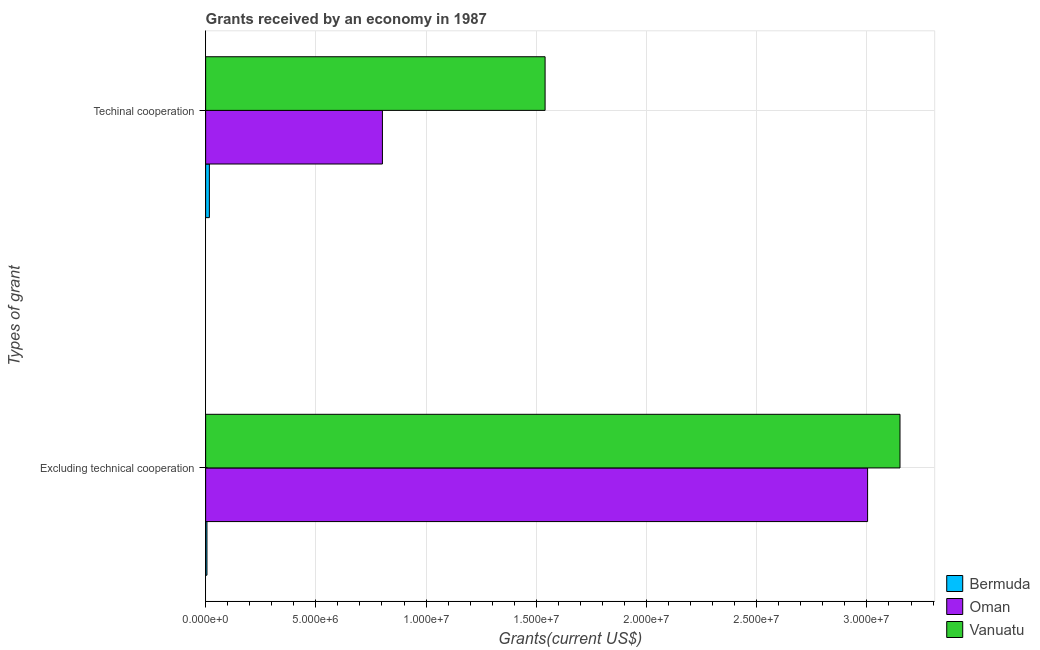How many groups of bars are there?
Provide a short and direct response. 2. Are the number of bars per tick equal to the number of legend labels?
Provide a short and direct response. Yes. What is the label of the 2nd group of bars from the top?
Give a very brief answer. Excluding technical cooperation. What is the amount of grants received(excluding technical cooperation) in Oman?
Your response must be concise. 3.00e+07. Across all countries, what is the maximum amount of grants received(including technical cooperation)?
Your answer should be compact. 1.54e+07. Across all countries, what is the minimum amount of grants received(including technical cooperation)?
Provide a short and direct response. 1.70e+05. In which country was the amount of grants received(excluding technical cooperation) maximum?
Provide a succinct answer. Vanuatu. In which country was the amount of grants received(including technical cooperation) minimum?
Keep it short and to the point. Bermuda. What is the total amount of grants received(including technical cooperation) in the graph?
Offer a very short reply. 2.36e+07. What is the difference between the amount of grants received(excluding technical cooperation) in Vanuatu and that in Bermuda?
Your answer should be very brief. 3.14e+07. What is the difference between the amount of grants received(excluding technical cooperation) in Vanuatu and the amount of grants received(including technical cooperation) in Bermuda?
Offer a terse response. 3.13e+07. What is the average amount of grants received(including technical cooperation) per country?
Ensure brevity in your answer.  7.86e+06. What is the difference between the amount of grants received(excluding technical cooperation) and amount of grants received(including technical cooperation) in Bermuda?
Make the answer very short. -1.10e+05. What is the ratio of the amount of grants received(excluding technical cooperation) in Vanuatu to that in Bermuda?
Ensure brevity in your answer.  525. Is the amount of grants received(including technical cooperation) in Vanuatu less than that in Bermuda?
Offer a very short reply. No. What does the 3rd bar from the top in Excluding technical cooperation represents?
Ensure brevity in your answer.  Bermuda. What does the 2nd bar from the bottom in Excluding technical cooperation represents?
Your answer should be compact. Oman. Are all the bars in the graph horizontal?
Provide a succinct answer. Yes. How many countries are there in the graph?
Ensure brevity in your answer.  3. What is the difference between two consecutive major ticks on the X-axis?
Offer a very short reply. 5.00e+06. Are the values on the major ticks of X-axis written in scientific E-notation?
Offer a very short reply. Yes. Does the graph contain any zero values?
Give a very brief answer. No. Does the graph contain grids?
Your response must be concise. Yes. Where does the legend appear in the graph?
Your answer should be compact. Bottom right. How many legend labels are there?
Ensure brevity in your answer.  3. How are the legend labels stacked?
Make the answer very short. Vertical. What is the title of the graph?
Provide a short and direct response. Grants received by an economy in 1987. What is the label or title of the X-axis?
Offer a very short reply. Grants(current US$). What is the label or title of the Y-axis?
Make the answer very short. Types of grant. What is the Grants(current US$) of Bermuda in Excluding technical cooperation?
Your response must be concise. 6.00e+04. What is the Grants(current US$) of Oman in Excluding technical cooperation?
Offer a very short reply. 3.00e+07. What is the Grants(current US$) in Vanuatu in Excluding technical cooperation?
Keep it short and to the point. 3.15e+07. What is the Grants(current US$) in Bermuda in Techinal cooperation?
Give a very brief answer. 1.70e+05. What is the Grants(current US$) of Oman in Techinal cooperation?
Provide a short and direct response. 8.02e+06. What is the Grants(current US$) in Vanuatu in Techinal cooperation?
Provide a succinct answer. 1.54e+07. Across all Types of grant, what is the maximum Grants(current US$) of Bermuda?
Give a very brief answer. 1.70e+05. Across all Types of grant, what is the maximum Grants(current US$) in Oman?
Make the answer very short. 3.00e+07. Across all Types of grant, what is the maximum Grants(current US$) of Vanuatu?
Your answer should be very brief. 3.15e+07. Across all Types of grant, what is the minimum Grants(current US$) in Bermuda?
Your response must be concise. 6.00e+04. Across all Types of grant, what is the minimum Grants(current US$) in Oman?
Your answer should be very brief. 8.02e+06. Across all Types of grant, what is the minimum Grants(current US$) of Vanuatu?
Provide a succinct answer. 1.54e+07. What is the total Grants(current US$) of Oman in the graph?
Your answer should be very brief. 3.80e+07. What is the total Grants(current US$) of Vanuatu in the graph?
Your response must be concise. 4.69e+07. What is the difference between the Grants(current US$) in Oman in Excluding technical cooperation and that in Techinal cooperation?
Make the answer very short. 2.20e+07. What is the difference between the Grants(current US$) in Vanuatu in Excluding technical cooperation and that in Techinal cooperation?
Provide a short and direct response. 1.61e+07. What is the difference between the Grants(current US$) of Bermuda in Excluding technical cooperation and the Grants(current US$) of Oman in Techinal cooperation?
Your answer should be compact. -7.96e+06. What is the difference between the Grants(current US$) of Bermuda in Excluding technical cooperation and the Grants(current US$) of Vanuatu in Techinal cooperation?
Your answer should be very brief. -1.53e+07. What is the difference between the Grants(current US$) of Oman in Excluding technical cooperation and the Grants(current US$) of Vanuatu in Techinal cooperation?
Make the answer very short. 1.46e+07. What is the average Grants(current US$) in Bermuda per Types of grant?
Your answer should be compact. 1.15e+05. What is the average Grants(current US$) in Oman per Types of grant?
Your answer should be very brief. 1.90e+07. What is the average Grants(current US$) in Vanuatu per Types of grant?
Your answer should be very brief. 2.34e+07. What is the difference between the Grants(current US$) of Bermuda and Grants(current US$) of Oman in Excluding technical cooperation?
Make the answer very short. -3.00e+07. What is the difference between the Grants(current US$) of Bermuda and Grants(current US$) of Vanuatu in Excluding technical cooperation?
Ensure brevity in your answer.  -3.14e+07. What is the difference between the Grants(current US$) of Oman and Grants(current US$) of Vanuatu in Excluding technical cooperation?
Ensure brevity in your answer.  -1.47e+06. What is the difference between the Grants(current US$) of Bermuda and Grants(current US$) of Oman in Techinal cooperation?
Your response must be concise. -7.85e+06. What is the difference between the Grants(current US$) of Bermuda and Grants(current US$) of Vanuatu in Techinal cooperation?
Give a very brief answer. -1.52e+07. What is the difference between the Grants(current US$) of Oman and Grants(current US$) of Vanuatu in Techinal cooperation?
Offer a terse response. -7.38e+06. What is the ratio of the Grants(current US$) of Bermuda in Excluding technical cooperation to that in Techinal cooperation?
Your answer should be very brief. 0.35. What is the ratio of the Grants(current US$) of Oman in Excluding technical cooperation to that in Techinal cooperation?
Make the answer very short. 3.74. What is the ratio of the Grants(current US$) in Vanuatu in Excluding technical cooperation to that in Techinal cooperation?
Offer a very short reply. 2.05. What is the difference between the highest and the second highest Grants(current US$) in Oman?
Give a very brief answer. 2.20e+07. What is the difference between the highest and the second highest Grants(current US$) of Vanuatu?
Give a very brief answer. 1.61e+07. What is the difference between the highest and the lowest Grants(current US$) of Oman?
Your response must be concise. 2.20e+07. What is the difference between the highest and the lowest Grants(current US$) in Vanuatu?
Your answer should be compact. 1.61e+07. 